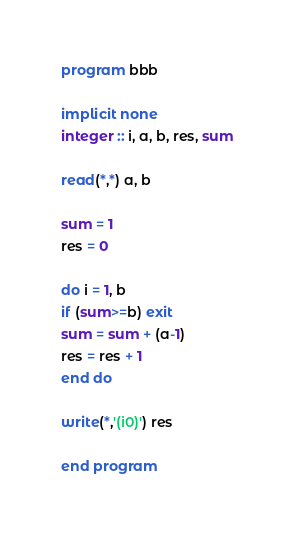<code> <loc_0><loc_0><loc_500><loc_500><_FORTRAN_>program bbb

implicit none
integer :: i, a, b, res, sum

read(*,*) a, b

sum = 1
res = 0

do i = 1, b
if (sum>=b) exit
sum = sum + (a-1)
res = res + 1
end do

write(*,'(i0)') res

end program</code> 